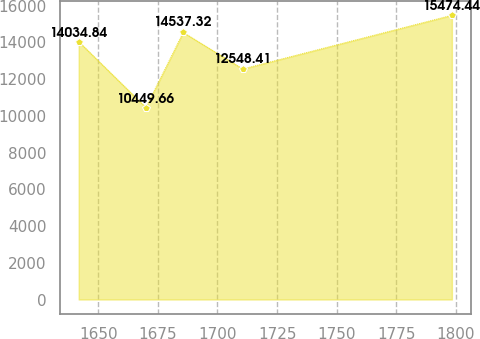<chart> <loc_0><loc_0><loc_500><loc_500><line_chart><ecel><fcel>Unnamed: 1<nl><fcel>1641.82<fcel>14034.8<nl><fcel>1669.98<fcel>10449.7<nl><fcel>1685.63<fcel>14537.3<nl><fcel>1710.58<fcel>12548.4<nl><fcel>1798.28<fcel>15474.4<nl></chart> 